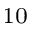<formula> <loc_0><loc_0><loc_500><loc_500>_ { 1 0 }</formula> 